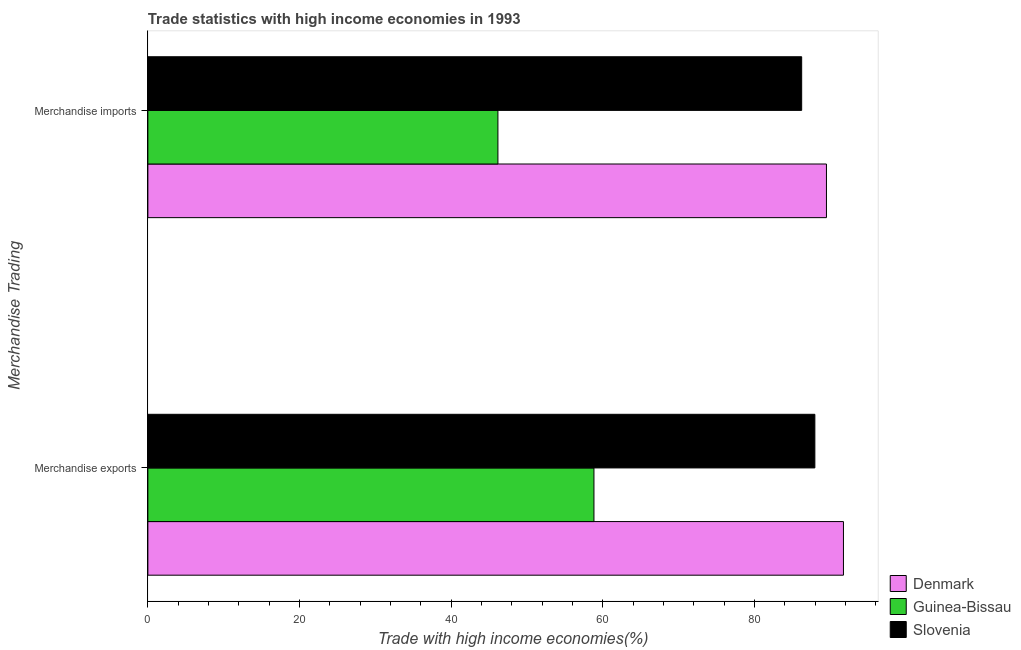How many different coloured bars are there?
Give a very brief answer. 3. How many groups of bars are there?
Make the answer very short. 2. How many bars are there on the 2nd tick from the top?
Your answer should be very brief. 3. How many bars are there on the 1st tick from the bottom?
Your answer should be compact. 3. What is the merchandise imports in Denmark?
Ensure brevity in your answer.  89.5. Across all countries, what is the maximum merchandise imports?
Provide a succinct answer. 89.5. Across all countries, what is the minimum merchandise exports?
Give a very brief answer. 58.84. In which country was the merchandise exports maximum?
Provide a short and direct response. Denmark. In which country was the merchandise exports minimum?
Your answer should be compact. Guinea-Bissau. What is the total merchandise imports in the graph?
Provide a short and direct response. 221.91. What is the difference between the merchandise exports in Slovenia and that in Guinea-Bissau?
Give a very brief answer. 29.14. What is the difference between the merchandise exports in Guinea-Bissau and the merchandise imports in Slovenia?
Ensure brevity in your answer.  -27.4. What is the average merchandise exports per country?
Keep it short and to the point. 79.52. What is the difference between the merchandise exports and merchandise imports in Denmark?
Offer a terse response. 2.24. In how many countries, is the merchandise exports greater than 20 %?
Provide a short and direct response. 3. What is the ratio of the merchandise exports in Denmark to that in Guinea-Bissau?
Ensure brevity in your answer.  1.56. Is the merchandise exports in Slovenia less than that in Denmark?
Your response must be concise. Yes. What does the 2nd bar from the top in Merchandise exports represents?
Ensure brevity in your answer.  Guinea-Bissau. What does the 3rd bar from the bottom in Merchandise exports represents?
Make the answer very short. Slovenia. How many countries are there in the graph?
Provide a short and direct response. 3. Are the values on the major ticks of X-axis written in scientific E-notation?
Provide a succinct answer. No. Does the graph contain any zero values?
Your response must be concise. No. How are the legend labels stacked?
Keep it short and to the point. Vertical. What is the title of the graph?
Your response must be concise. Trade statistics with high income economies in 1993. Does "Other small states" appear as one of the legend labels in the graph?
Make the answer very short. No. What is the label or title of the X-axis?
Offer a terse response. Trade with high income economies(%). What is the label or title of the Y-axis?
Your answer should be very brief. Merchandise Trading. What is the Trade with high income economies(%) in Denmark in Merchandise exports?
Provide a succinct answer. 91.74. What is the Trade with high income economies(%) in Guinea-Bissau in Merchandise exports?
Offer a terse response. 58.84. What is the Trade with high income economies(%) of Slovenia in Merchandise exports?
Your response must be concise. 87.97. What is the Trade with high income economies(%) in Denmark in Merchandise imports?
Offer a very short reply. 89.5. What is the Trade with high income economies(%) in Guinea-Bissau in Merchandise imports?
Offer a terse response. 46.17. What is the Trade with high income economies(%) of Slovenia in Merchandise imports?
Provide a succinct answer. 86.23. Across all Merchandise Trading, what is the maximum Trade with high income economies(%) of Denmark?
Your response must be concise. 91.74. Across all Merchandise Trading, what is the maximum Trade with high income economies(%) of Guinea-Bissau?
Your response must be concise. 58.84. Across all Merchandise Trading, what is the maximum Trade with high income economies(%) of Slovenia?
Your response must be concise. 87.97. Across all Merchandise Trading, what is the minimum Trade with high income economies(%) of Denmark?
Give a very brief answer. 89.5. Across all Merchandise Trading, what is the minimum Trade with high income economies(%) in Guinea-Bissau?
Ensure brevity in your answer.  46.17. Across all Merchandise Trading, what is the minimum Trade with high income economies(%) in Slovenia?
Your response must be concise. 86.23. What is the total Trade with high income economies(%) of Denmark in the graph?
Keep it short and to the point. 181.25. What is the total Trade with high income economies(%) in Guinea-Bissau in the graph?
Your response must be concise. 105.01. What is the total Trade with high income economies(%) of Slovenia in the graph?
Keep it short and to the point. 174.21. What is the difference between the Trade with high income economies(%) in Denmark in Merchandise exports and that in Merchandise imports?
Keep it short and to the point. 2.24. What is the difference between the Trade with high income economies(%) in Guinea-Bissau in Merchandise exports and that in Merchandise imports?
Offer a terse response. 12.67. What is the difference between the Trade with high income economies(%) of Slovenia in Merchandise exports and that in Merchandise imports?
Provide a short and direct response. 1.74. What is the difference between the Trade with high income economies(%) of Denmark in Merchandise exports and the Trade with high income economies(%) of Guinea-Bissau in Merchandise imports?
Give a very brief answer. 45.57. What is the difference between the Trade with high income economies(%) in Denmark in Merchandise exports and the Trade with high income economies(%) in Slovenia in Merchandise imports?
Provide a succinct answer. 5.51. What is the difference between the Trade with high income economies(%) of Guinea-Bissau in Merchandise exports and the Trade with high income economies(%) of Slovenia in Merchandise imports?
Your response must be concise. -27.4. What is the average Trade with high income economies(%) in Denmark per Merchandise Trading?
Your answer should be very brief. 90.62. What is the average Trade with high income economies(%) of Guinea-Bissau per Merchandise Trading?
Ensure brevity in your answer.  52.5. What is the average Trade with high income economies(%) in Slovenia per Merchandise Trading?
Your answer should be very brief. 87.1. What is the difference between the Trade with high income economies(%) in Denmark and Trade with high income economies(%) in Guinea-Bissau in Merchandise exports?
Make the answer very short. 32.91. What is the difference between the Trade with high income economies(%) of Denmark and Trade with high income economies(%) of Slovenia in Merchandise exports?
Offer a very short reply. 3.77. What is the difference between the Trade with high income economies(%) in Guinea-Bissau and Trade with high income economies(%) in Slovenia in Merchandise exports?
Keep it short and to the point. -29.14. What is the difference between the Trade with high income economies(%) of Denmark and Trade with high income economies(%) of Guinea-Bissau in Merchandise imports?
Provide a succinct answer. 43.33. What is the difference between the Trade with high income economies(%) in Denmark and Trade with high income economies(%) in Slovenia in Merchandise imports?
Give a very brief answer. 3.27. What is the difference between the Trade with high income economies(%) in Guinea-Bissau and Trade with high income economies(%) in Slovenia in Merchandise imports?
Your answer should be compact. -40.06. What is the ratio of the Trade with high income economies(%) in Guinea-Bissau in Merchandise exports to that in Merchandise imports?
Provide a succinct answer. 1.27. What is the ratio of the Trade with high income economies(%) of Slovenia in Merchandise exports to that in Merchandise imports?
Offer a very short reply. 1.02. What is the difference between the highest and the second highest Trade with high income economies(%) of Denmark?
Provide a short and direct response. 2.24. What is the difference between the highest and the second highest Trade with high income economies(%) of Guinea-Bissau?
Offer a very short reply. 12.67. What is the difference between the highest and the second highest Trade with high income economies(%) of Slovenia?
Offer a very short reply. 1.74. What is the difference between the highest and the lowest Trade with high income economies(%) of Denmark?
Offer a very short reply. 2.24. What is the difference between the highest and the lowest Trade with high income economies(%) of Guinea-Bissau?
Keep it short and to the point. 12.67. What is the difference between the highest and the lowest Trade with high income economies(%) in Slovenia?
Your answer should be compact. 1.74. 